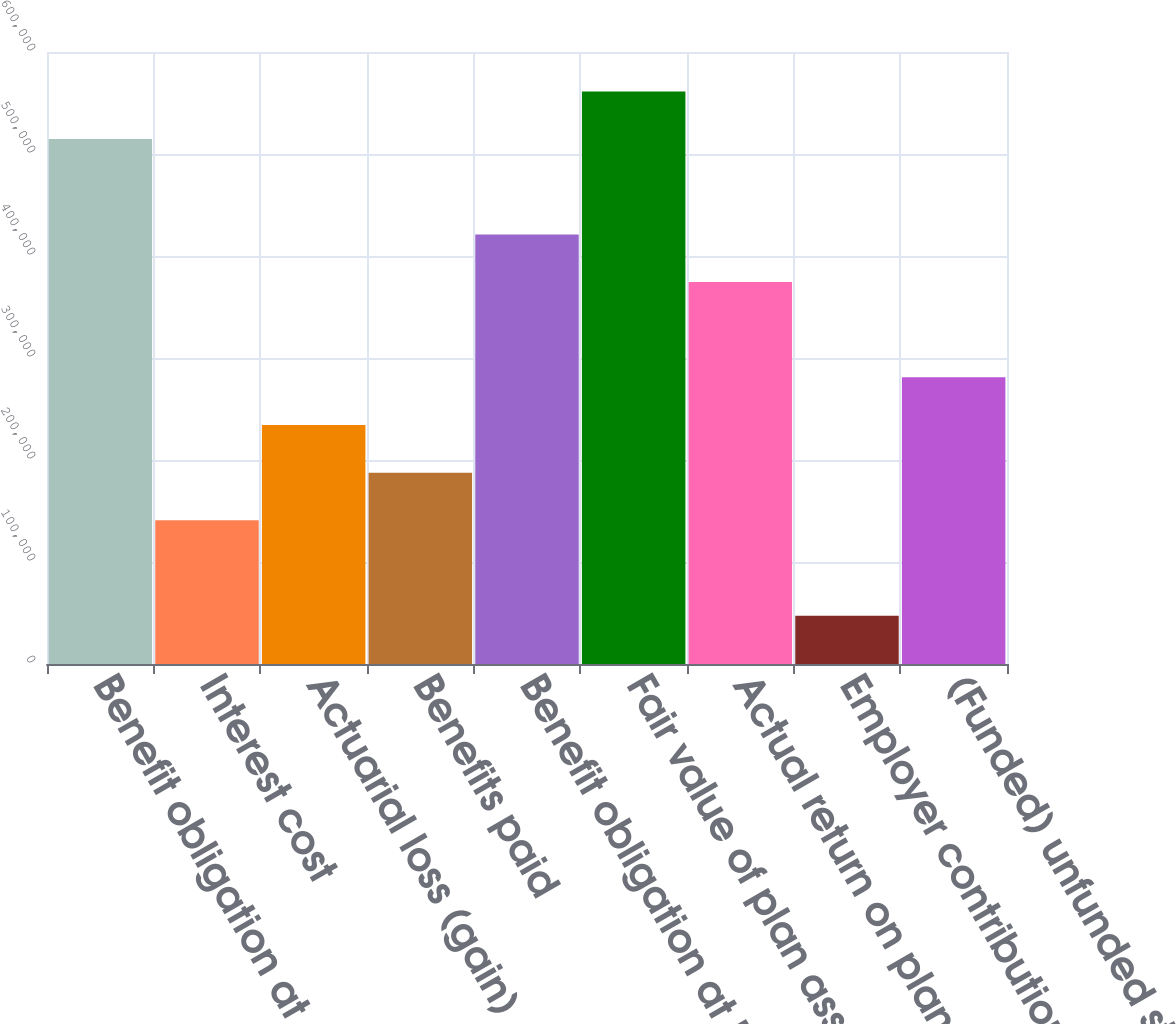<chart> <loc_0><loc_0><loc_500><loc_500><bar_chart><fcel>Benefit obligation at January<fcel>Interest cost<fcel>Actuarial loss (gain)<fcel>Benefits paid<fcel>Benefit obligation at December<fcel>Fair value of plan assets at<fcel>Actual return on plan assets<fcel>Employer contributions net<fcel>(Funded) unfunded status at<nl><fcel>514633<fcel>140864<fcel>234306<fcel>187585<fcel>421191<fcel>561354<fcel>374470<fcel>47421.2<fcel>281027<nl></chart> 